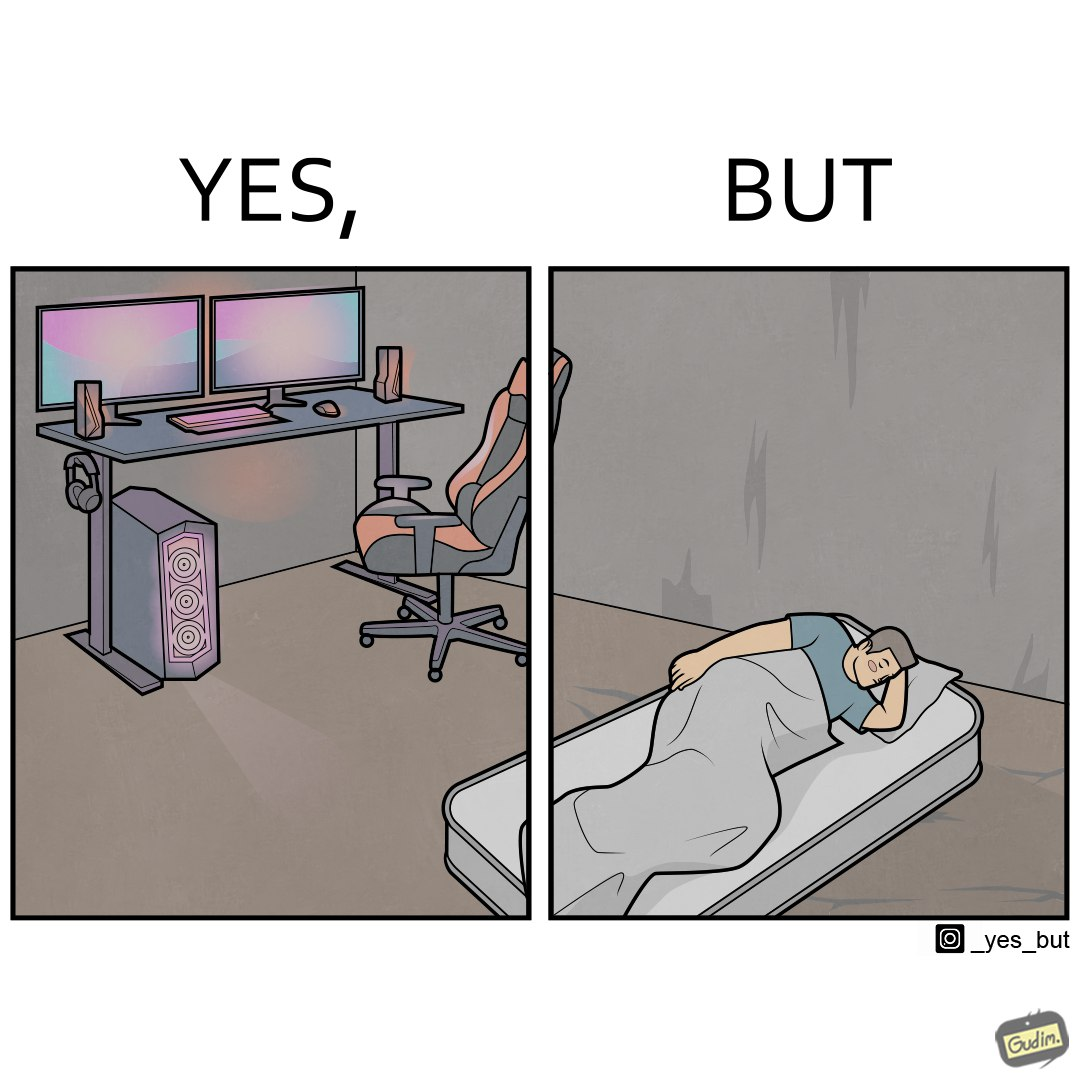Is there satirical content in this image? Yes, this image is satirical. 